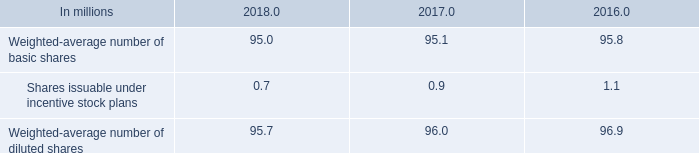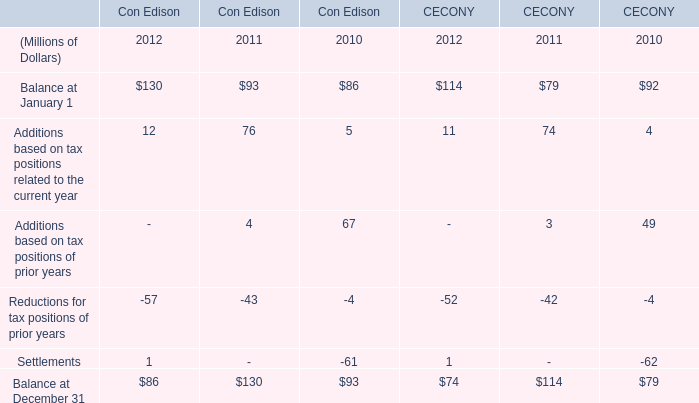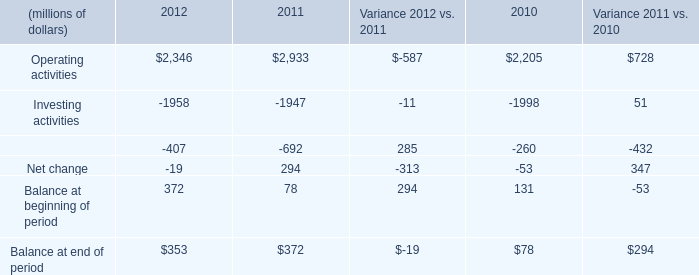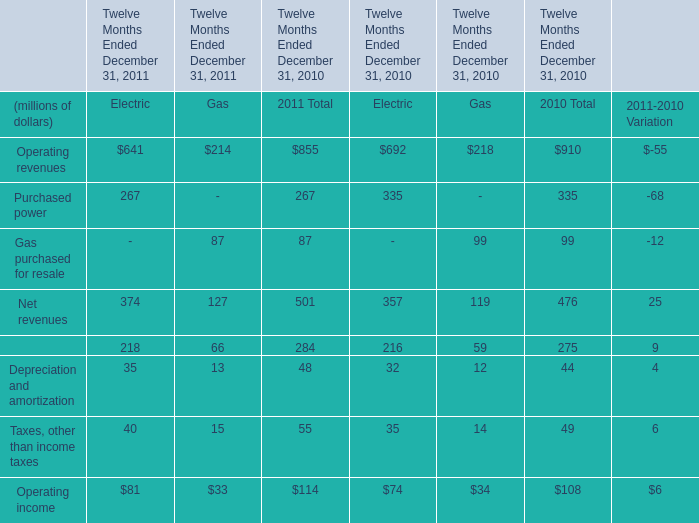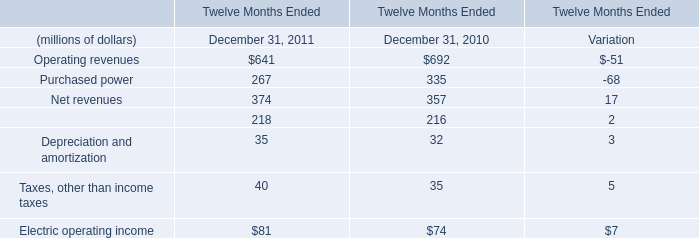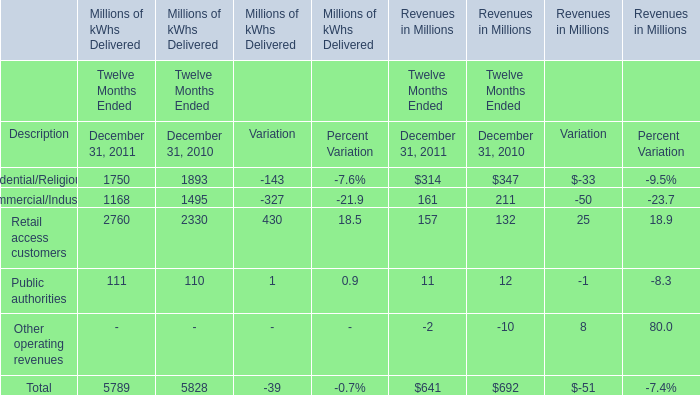In the year with largest amount of Operating income of Electric, what's the increasing rate of Net revenues of Electric? 
Computations: ((374 - 357) / 357)
Answer: 0.04762. 